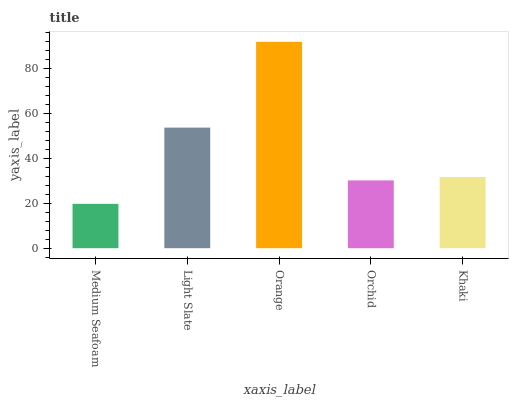Is Medium Seafoam the minimum?
Answer yes or no. Yes. Is Orange the maximum?
Answer yes or no. Yes. Is Light Slate the minimum?
Answer yes or no. No. Is Light Slate the maximum?
Answer yes or no. No. Is Light Slate greater than Medium Seafoam?
Answer yes or no. Yes. Is Medium Seafoam less than Light Slate?
Answer yes or no. Yes. Is Medium Seafoam greater than Light Slate?
Answer yes or no. No. Is Light Slate less than Medium Seafoam?
Answer yes or no. No. Is Khaki the high median?
Answer yes or no. Yes. Is Khaki the low median?
Answer yes or no. Yes. Is Orchid the high median?
Answer yes or no. No. Is Light Slate the low median?
Answer yes or no. No. 